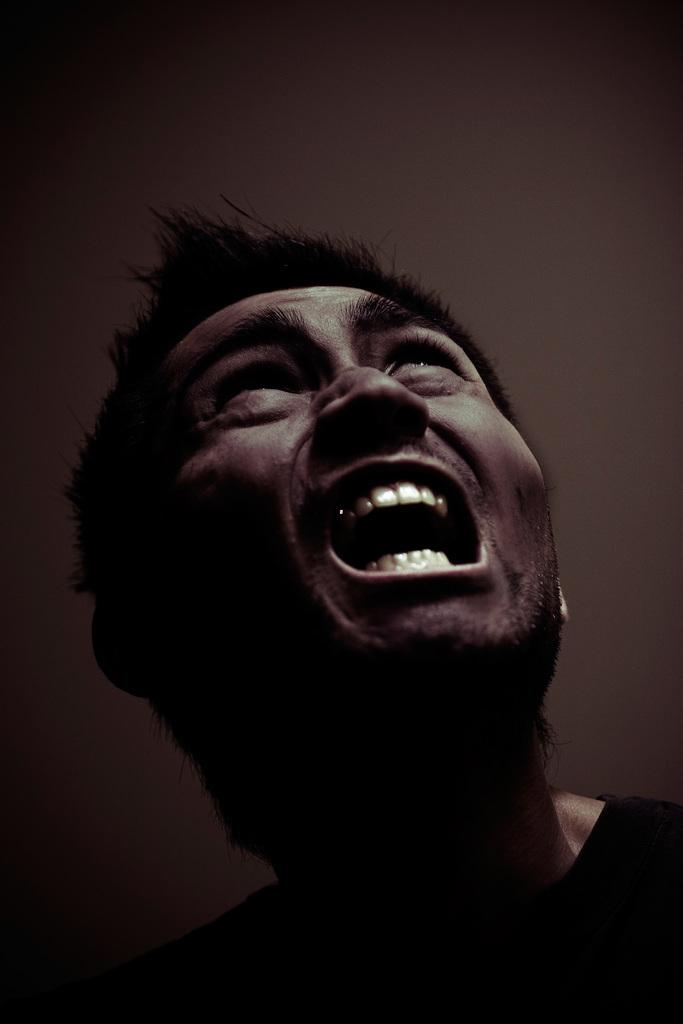What is the main subject of the image? There is a person in the image. What color scheme is used in the image? The image is in black and white. What type of station is visible in the image? There is no station present in the image; it features a person in a black and white setting. How many toes can be seen on the person's feet in the image? The image does not show the person's feet, so it is not possible to determine the number of toes. 